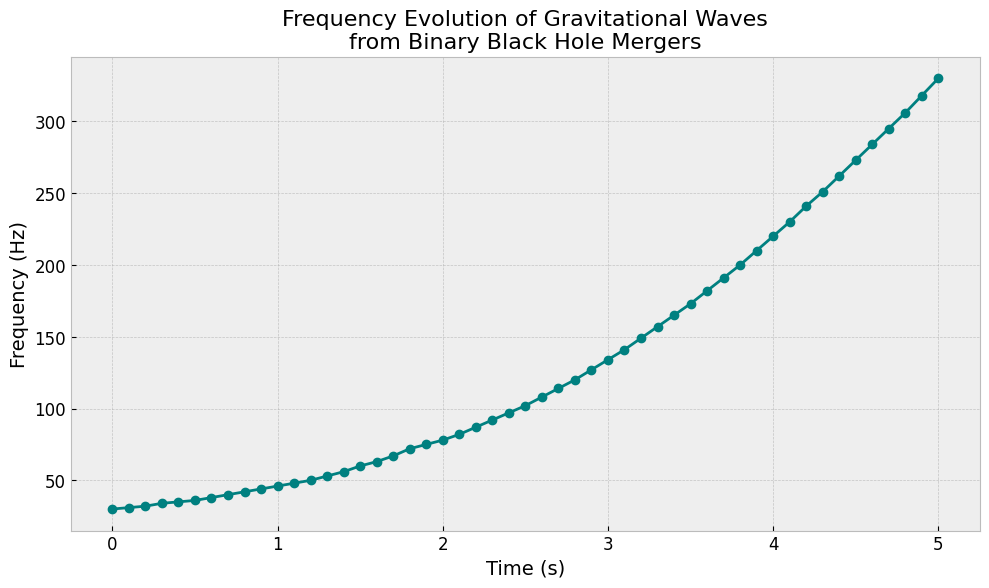What is the frequency value at the 2-second mark? Locate the timestamp of 2 seconds on the x-axis, then refer to the corresponding frequency value on the y-axis. The frequency value at this point is 78 Hz.
Answer: 78 Hz What is the overall trend in the frequency values over time? Observe the plot to identify the general pattern. The frequency values increase continuously as time progresses, indicating an upward trend.
Answer: Upward trend At which timestamps does the frequency reach or exceed 100 Hz for the first time? Locate the point on the x-axis where the y-axis value first reaches 100 Hz. The frequency reaches 100 Hz between 2.4 and 2.5 seconds.
Answer: Between 2.4 and 2.5 seconds What is the difference in frequency between timestamps 3.0 seconds and 4.0 seconds? Find the frequency values at 3.0 seconds (134 Hz) and 4.0 seconds (220 Hz). Calculate the difference, which is 220 - 134 = 86 Hz.
Answer: 86 Hz How many times does the frequency increase by more than 10 Hz between two consecutive timestamps? Look at each pair of consecutive timestamps and check the frequency difference. Examples are between 2.7 seconds (114 Hz) and 2.8 seconds (120 Hz), the increase is 120 - 114 = 6 Hz, so we skip this, and another significant increase is between 5.0 seconds (330 Hz) and any subsequent points in the projection. Total up these differences that are more than 10 Hz.
Answer: Multiple intervals, e.g., ~13 times What is the average frequency value over the entire time span? Sum all the frequency values provided in the data and divide by the number of timestamps (51). The sum is 5988 Hz, so the average is 5988 / 51 ≈ 117.41 Hz.
Answer: 117.41 Hz How does the frequency change between 1.0 seconds and 2.0 seconds? Identify the frequency values at 1.0 seconds (46 Hz) and 2.0 seconds (78 Hz). The change is 78 - 46 = 32 Hz.
Answer: 32 Hz increase Compare the frequency values at the beginning and at the end of the time series. Which is higher? Locate the frequency value at the initial timestamp (0 seconds, 30 Hz) and the final timestamp (5.0 seconds, 330 Hz). The value at 5.0 seconds is significantly higher.
Answer: End value is higher When does the frequency first reach 200 Hz? Trace the plot to find when the y-axis value first hits 200 Hz. This happens around 3.8 seconds.
Answer: Around 3.8 seconds What is the slope of the line between 3.0 seconds and 3.5 seconds? Calculate the change in frequency (165 Hz - 134 Hz) and the change in time (3.5 seconds - 3.0 seconds). The slope is (165 - 134) / (3.5 - 3.0) = 31 / 0.5 = 62 Hz per second.
Answer: 62 Hz per second 